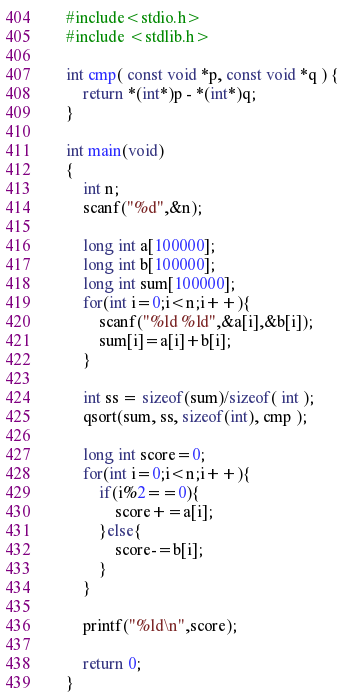<code> <loc_0><loc_0><loc_500><loc_500><_C_>    #include<stdio.h>
    #include <stdlib.h>
     
    int cmp( const void *p, const void *q ) {
        return *(int*)p - *(int*)q;
    }
     
    int main(void)
    {
        int n;
        scanf("%d",&n);
        
        long int a[100000];
        long int b[100000];
        long int sum[100000];
        for(int i=0;i<n;i++){
            scanf("%ld %ld",&a[i],&b[i]);
            sum[i]=a[i]+b[i];
        }
        
        int ss = sizeof(sum)/sizeof( int );
        qsort(sum, ss, sizeof(int), cmp );
        
        long int score=0;
        for(int i=0;i<n;i++){
            if(i%2==0){
                score+=a[i];
            }else{
                score-=b[i];
            }
        }
        
        printf("%ld\n",score);
        
        return 0;
    }</code> 